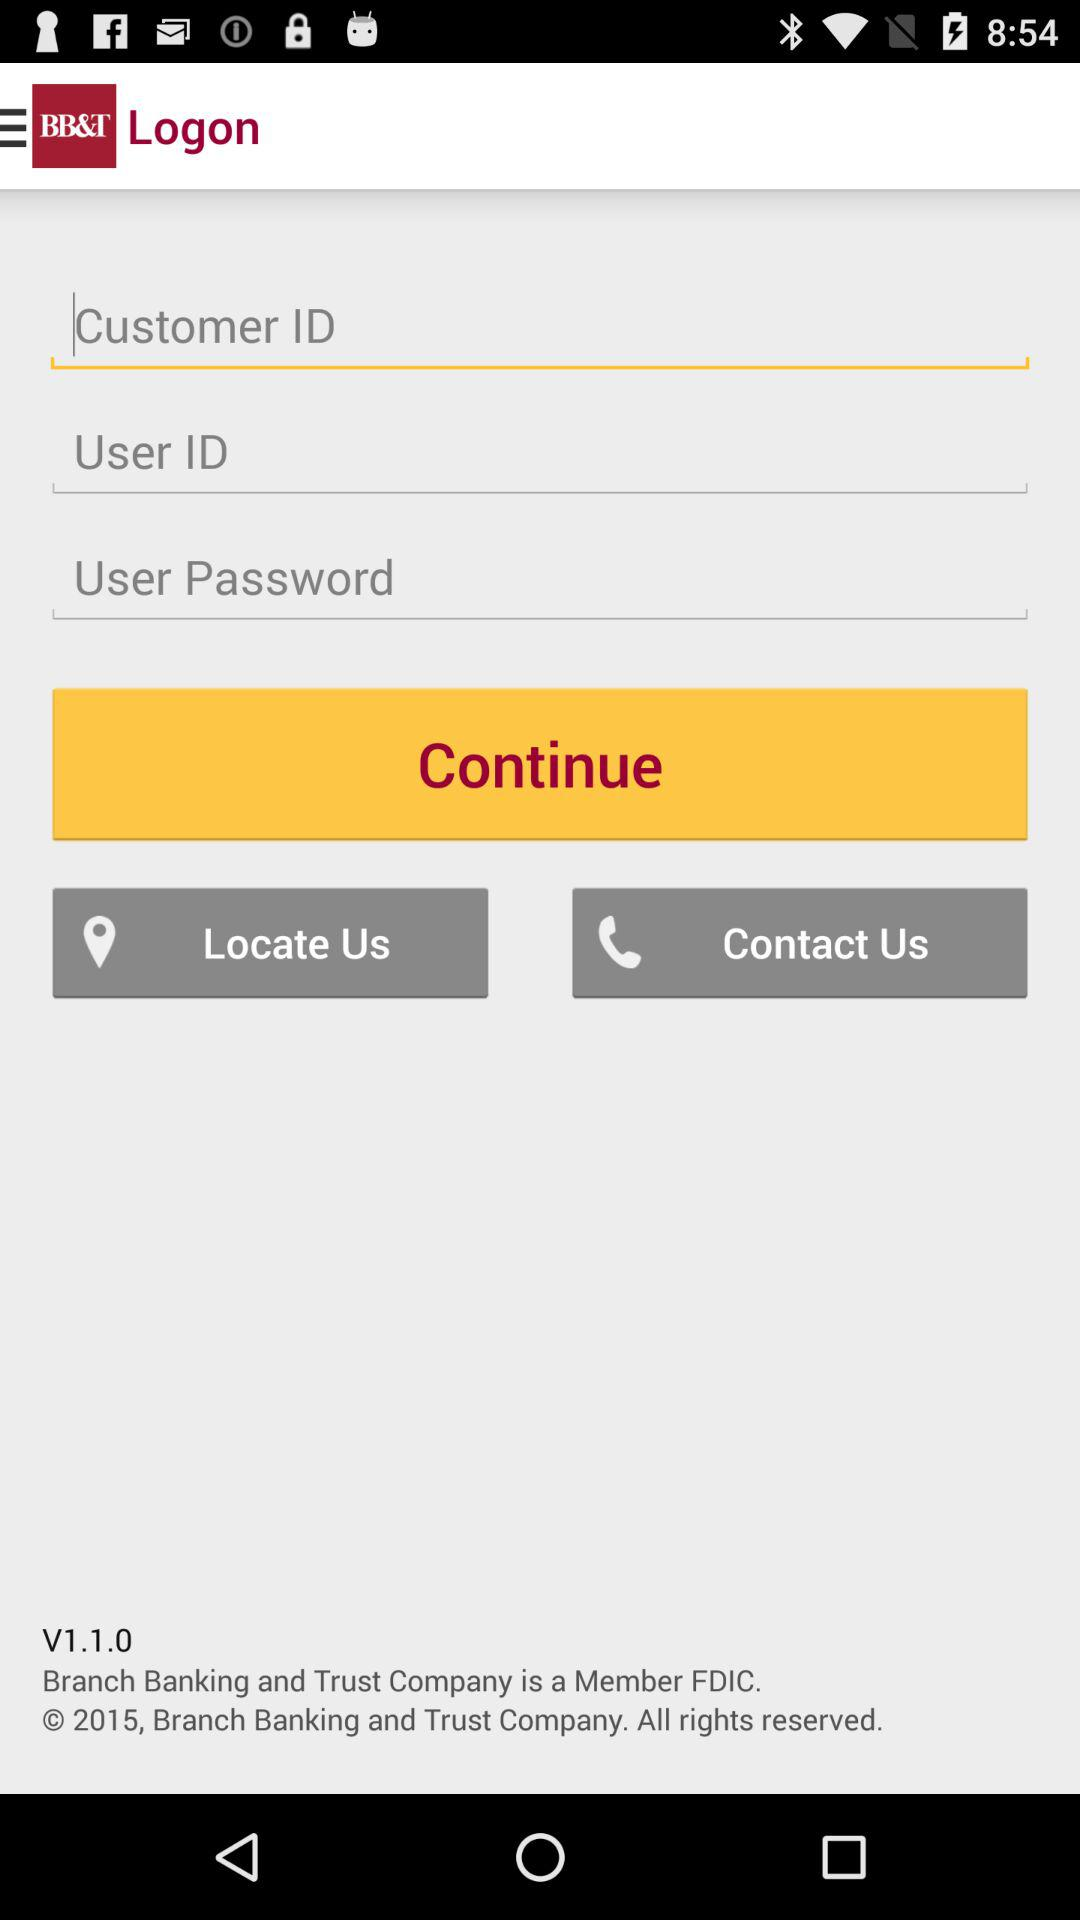What is the application name? The application name is "BB&T". 